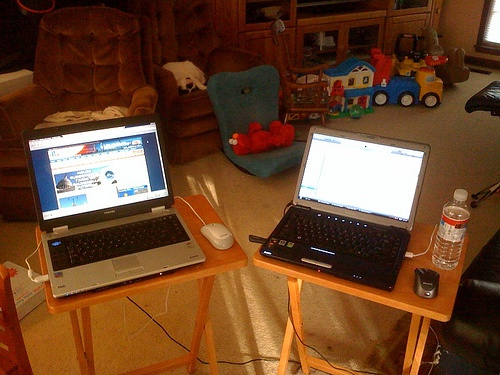Describe the objects in this image and their specific colors. I can see laptop in black, white, olive, and maroon tones, laptop in black, white, gray, and maroon tones, couch in black, maroon, and brown tones, chair in black, maroon, and brown tones, and bottle in black, brown, gray, tan, and maroon tones in this image. 